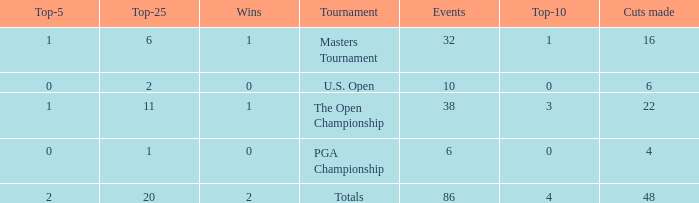Parse the full table. {'header': ['Top-5', 'Top-25', 'Wins', 'Tournament', 'Events', 'Top-10', 'Cuts made'], 'rows': [['1', '6', '1', 'Masters Tournament', '32', '1', '16'], ['0', '2', '0', 'U.S. Open', '10', '0', '6'], ['1', '11', '1', 'The Open Championship', '38', '3', '22'], ['0', '1', '0', 'PGA Championship', '6', '0', '4'], ['2', '20', '2', 'Totals', '86', '4', '48']]} Tell me the total number of events for tournament of masters tournament and top 25 less than 6 0.0. 